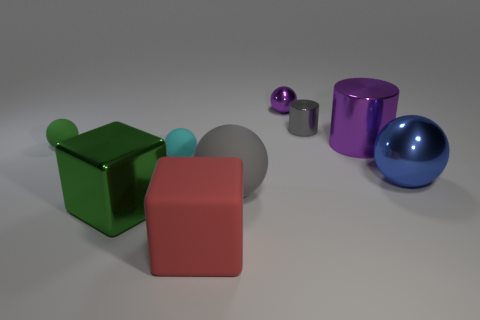How many balls are either big red metallic things or big green shiny objects?
Provide a short and direct response. 0. Is there anything else that is the same material as the blue thing?
Your response must be concise. Yes. There is a gray object that is in front of the purple object that is in front of the tiny metallic object to the right of the tiny metallic ball; what is its material?
Keep it short and to the point. Rubber. What material is the thing that is the same color as the tiny shiny cylinder?
Keep it short and to the point. Rubber. What number of green things have the same material as the blue sphere?
Offer a very short reply. 1. Does the purple metallic object that is behind the purple metal cylinder have the same size as the small green object?
Offer a very short reply. Yes. There is another tiny thing that is the same material as the small cyan object; what is its color?
Offer a terse response. Green. Is there anything else that is the same size as the purple cylinder?
Give a very brief answer. Yes. What number of purple metal things are to the left of the blue metal thing?
Your answer should be compact. 2. Do the shiny thing that is left of the gray rubber ball and the tiny sphere that is on the right side of the large red cube have the same color?
Your answer should be compact. No. 